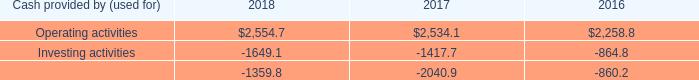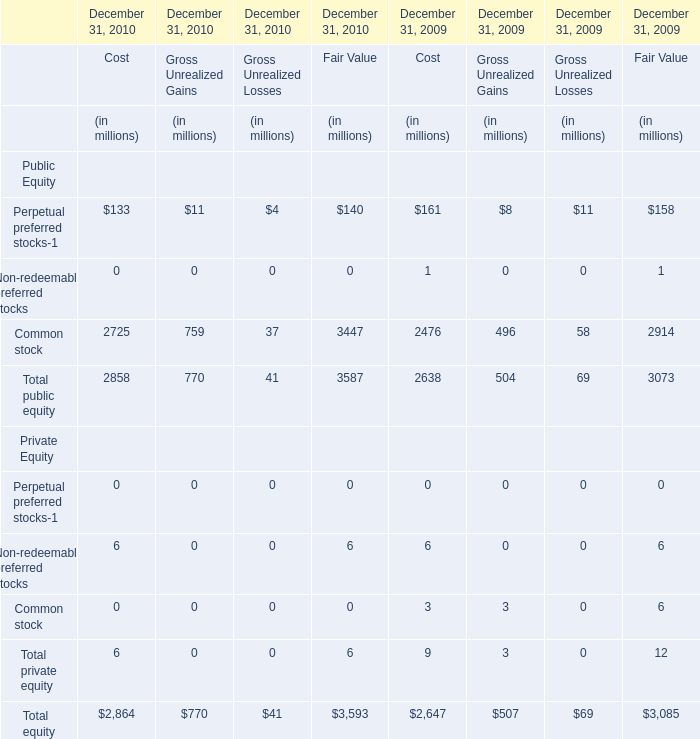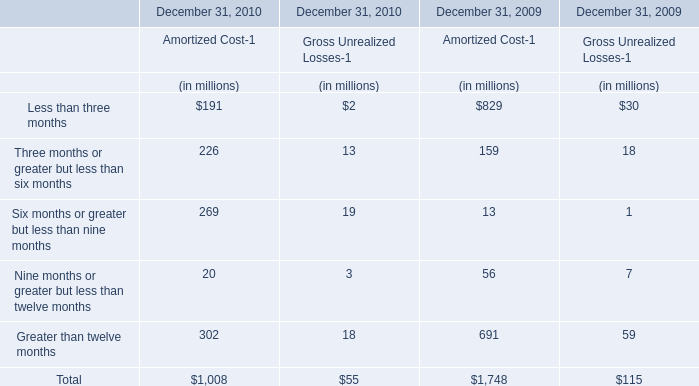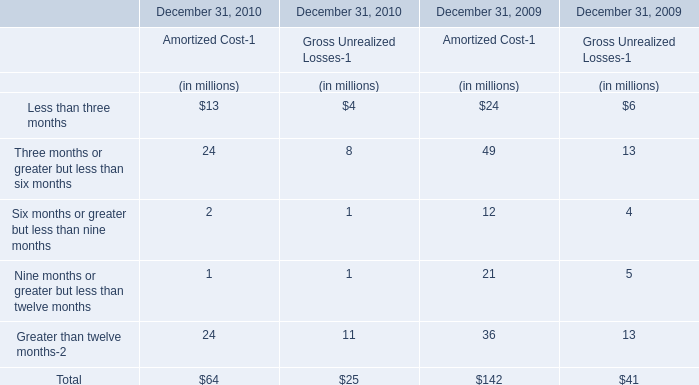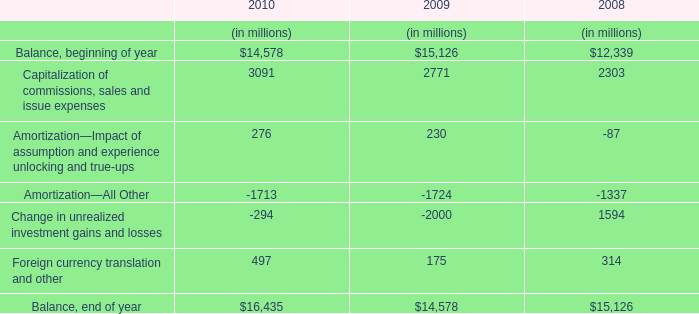Which year is common stock of public equity for fair value the most? 
Answer: 2010. 